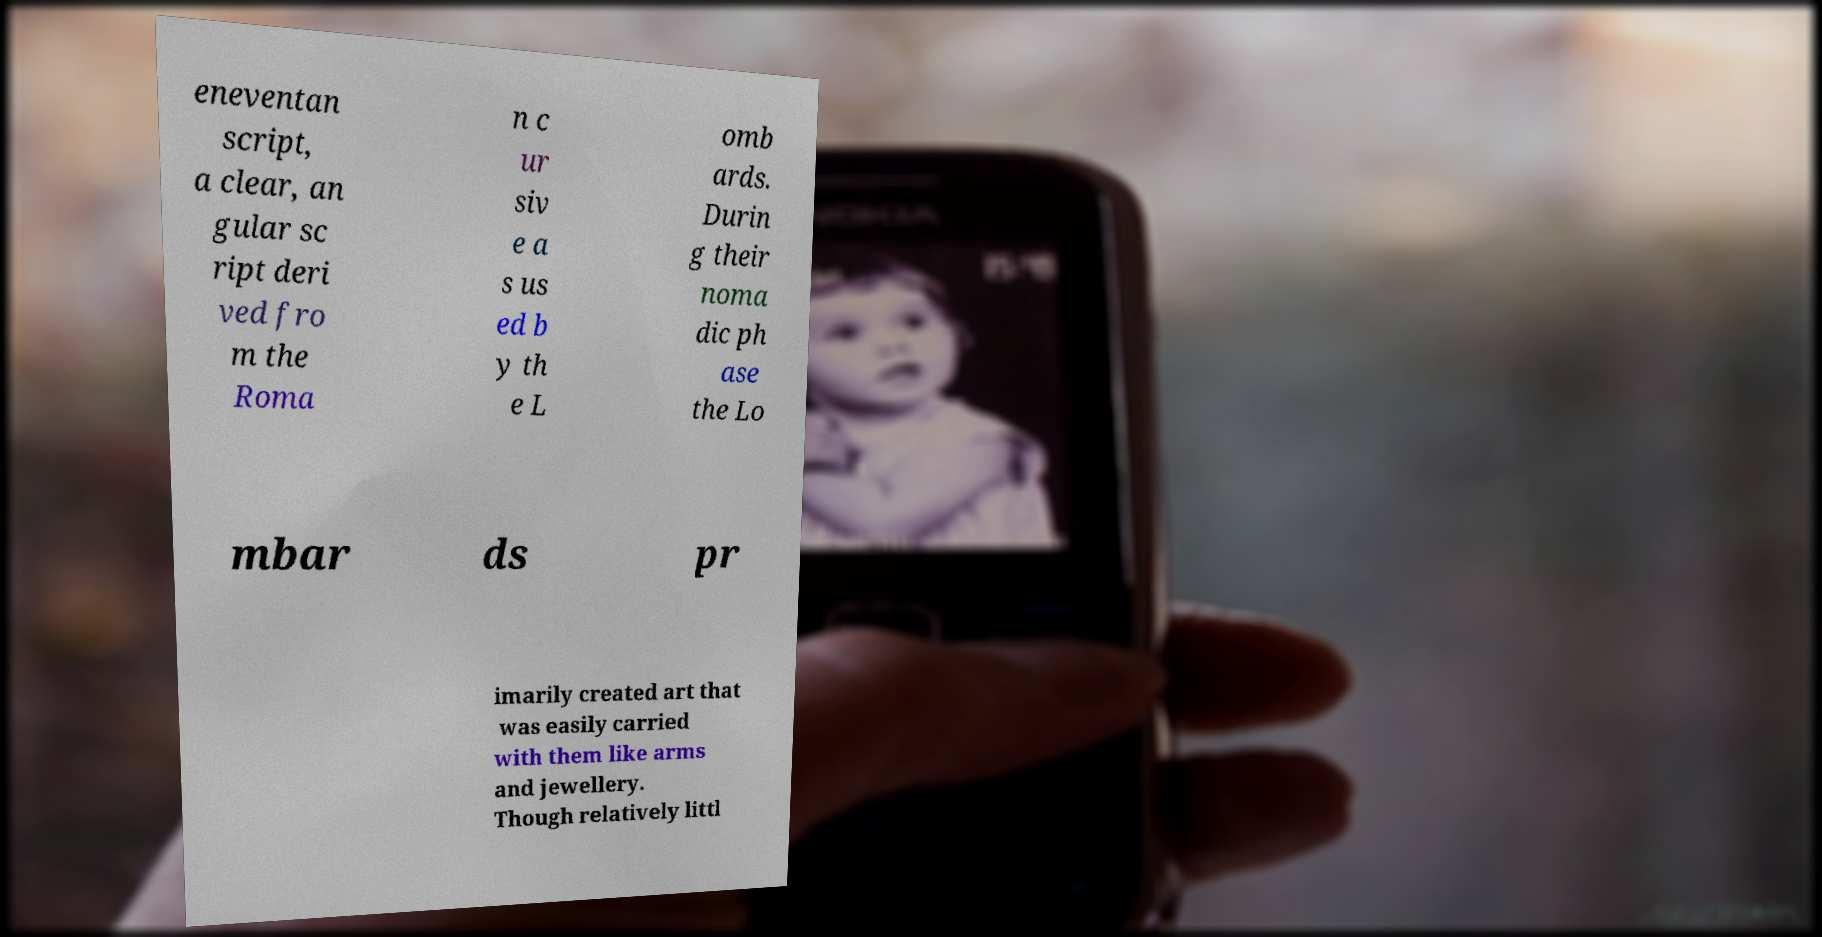I need the written content from this picture converted into text. Can you do that? eneventan script, a clear, an gular sc ript deri ved fro m the Roma n c ur siv e a s us ed b y th e L omb ards. Durin g their noma dic ph ase the Lo mbar ds pr imarily created art that was easily carried with them like arms and jewellery. Though relatively littl 